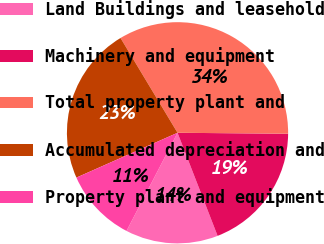Convert chart to OTSL. <chart><loc_0><loc_0><loc_500><loc_500><pie_chart><fcel>Land Buildings and leasehold<fcel>Machinery and equipment<fcel>Total property plant and<fcel>Accumulated depreciation and<fcel>Property plant and equipment<nl><fcel>13.53%<fcel>18.96%<fcel>33.75%<fcel>23.02%<fcel>10.73%<nl></chart> 